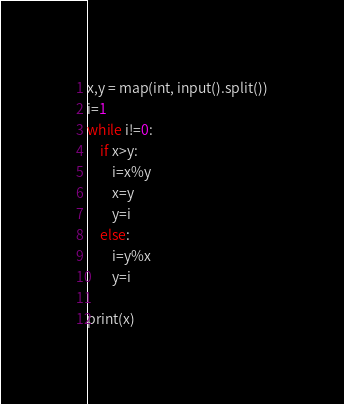<code> <loc_0><loc_0><loc_500><loc_500><_Python_>x,y = map(int, input().split())
i=1
while i!=0:
    if x>y:
        i=x%y
        x=y
        y=i
    else:
        i=y%x
        y=i

print(x)

</code> 